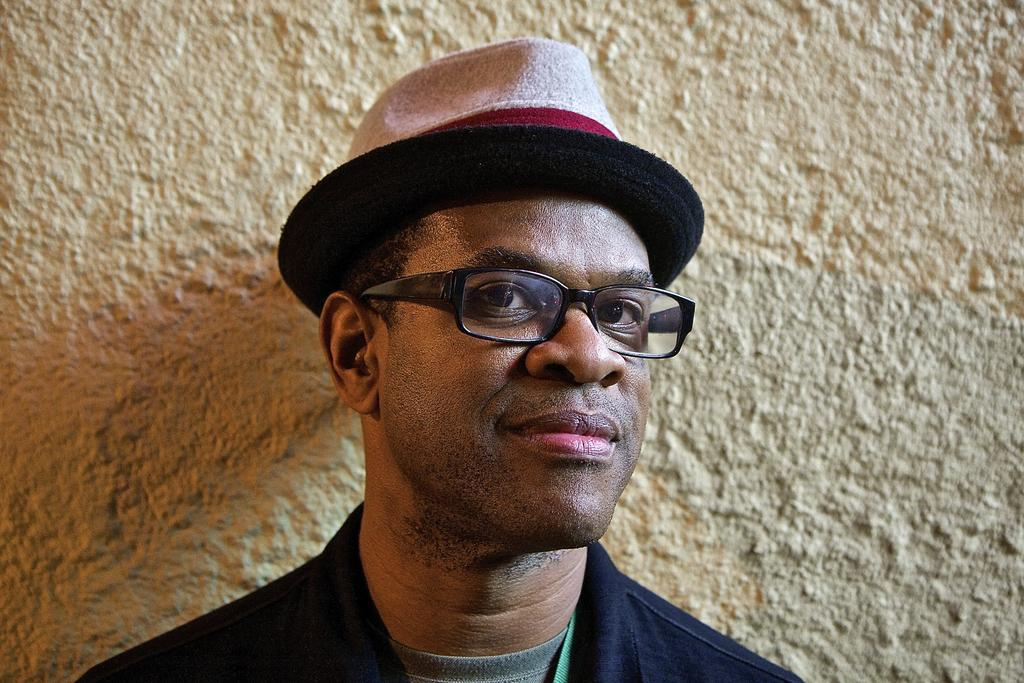What is present in the image? There is a man in the image. Can you describe the man's attire? The man is wearing a hat and glasses. What is visible behind the man in the image? There is a wall visible behind the man in the image. Where is the drain located in the image? There is no drain present in the image. What type of cattle can be seen grazing in the background of the image? There is no cattle present in the image. 